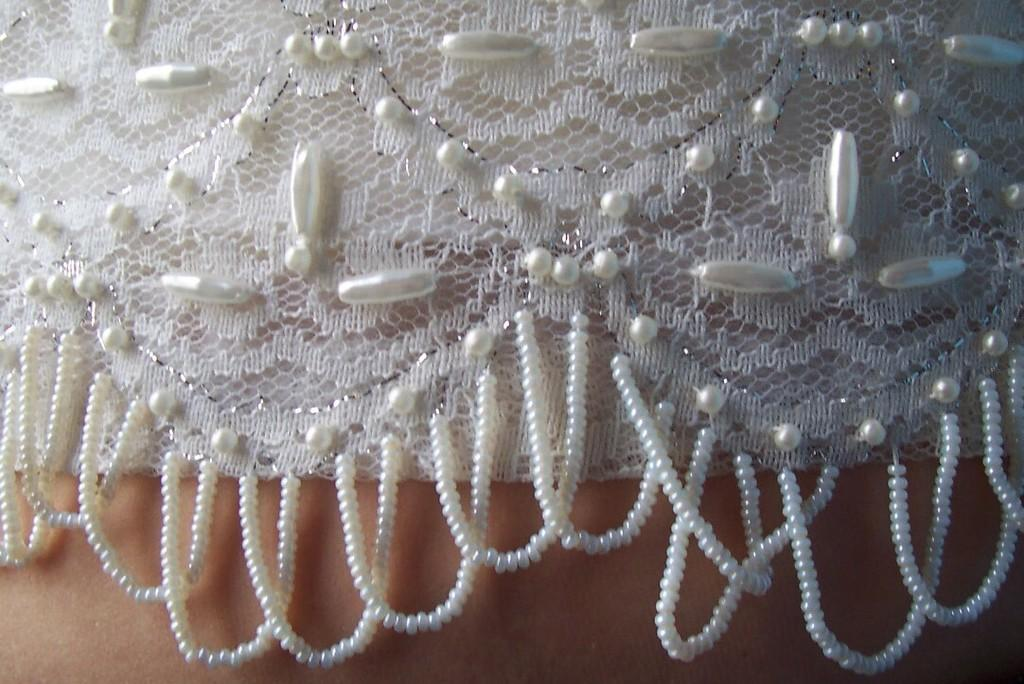What color is the cloth visible in the image? The cloth in the image is white. What is attached to the wall in the image? There are pearls attached to the wall in the image. What type of bird can be seen in the image? There is no bird present in the image. 